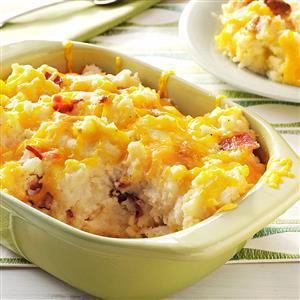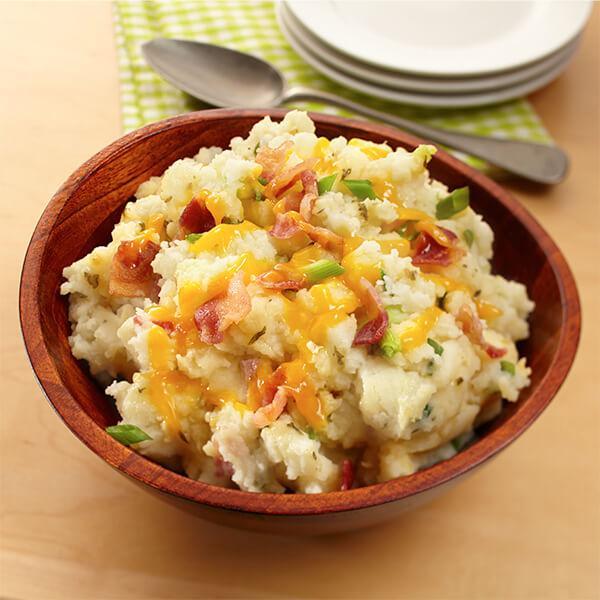The first image is the image on the left, the second image is the image on the right. Assess this claim about the two images: "The right image includes a round brown bowl with mashed potatoes in it and a spoon.". Correct or not? Answer yes or no. Yes. 